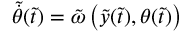<formula> <loc_0><loc_0><loc_500><loc_500>\tilde { \dot { \theta } } ( \tilde { t } ) = \tilde { \omega } \left ( \tilde { y } ( \tilde { t } ) , \theta ( \tilde { t } ) \right )</formula> 